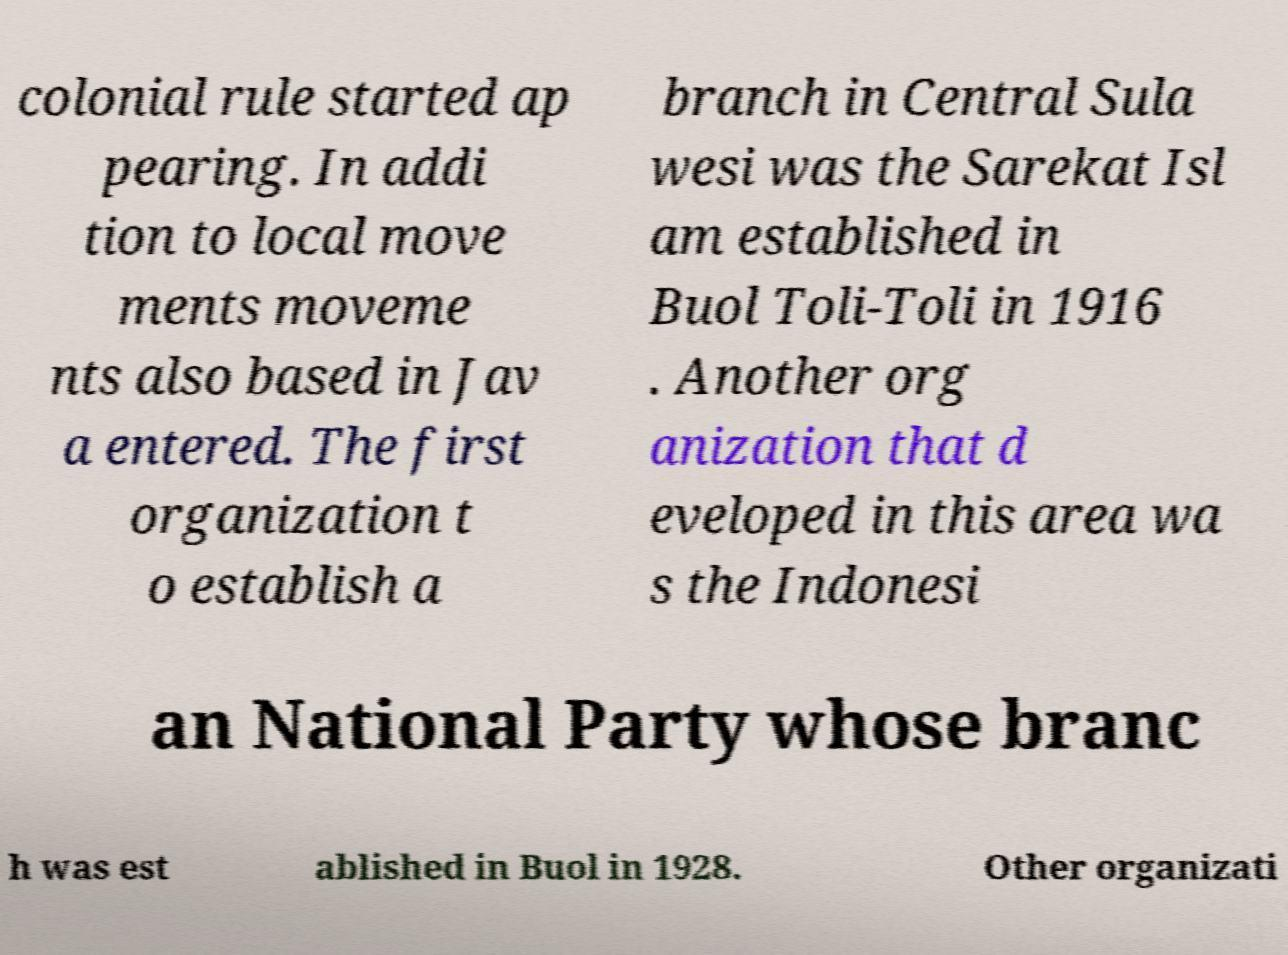There's text embedded in this image that I need extracted. Can you transcribe it verbatim? colonial rule started ap pearing. In addi tion to local move ments moveme nts also based in Jav a entered. The first organization t o establish a branch in Central Sula wesi was the Sarekat Isl am established in Buol Toli-Toli in 1916 . Another org anization that d eveloped in this area wa s the Indonesi an National Party whose branc h was est ablished in Buol in 1928. Other organizati 